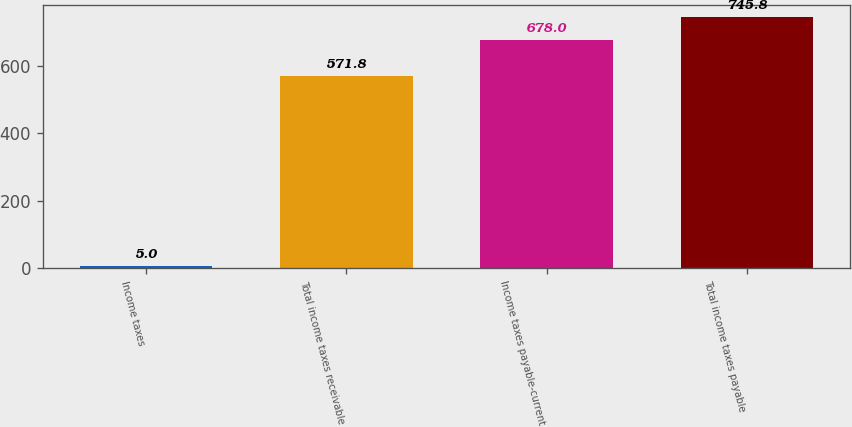<chart> <loc_0><loc_0><loc_500><loc_500><bar_chart><fcel>Income taxes<fcel>Total income taxes receivable<fcel>Income taxes payable-current<fcel>Total income taxes payable<nl><fcel>5<fcel>571.8<fcel>678<fcel>745.8<nl></chart> 